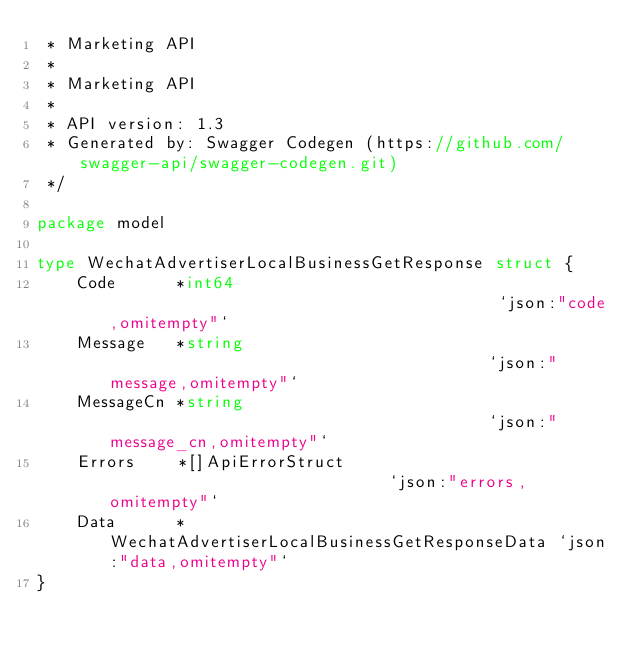Convert code to text. <code><loc_0><loc_0><loc_500><loc_500><_Go_> * Marketing API
 *
 * Marketing API
 *
 * API version: 1.3
 * Generated by: Swagger Codegen (https://github.com/swagger-api/swagger-codegen.git)
 */

package model

type WechatAdvertiserLocalBusinessGetResponse struct {
	Code      *int64                                        `json:"code,omitempty"`
	Message   *string                                       `json:"message,omitempty"`
	MessageCn *string                                       `json:"message_cn,omitempty"`
	Errors    *[]ApiErrorStruct                             `json:"errors,omitempty"`
	Data      *WechatAdvertiserLocalBusinessGetResponseData `json:"data,omitempty"`
}
</code> 